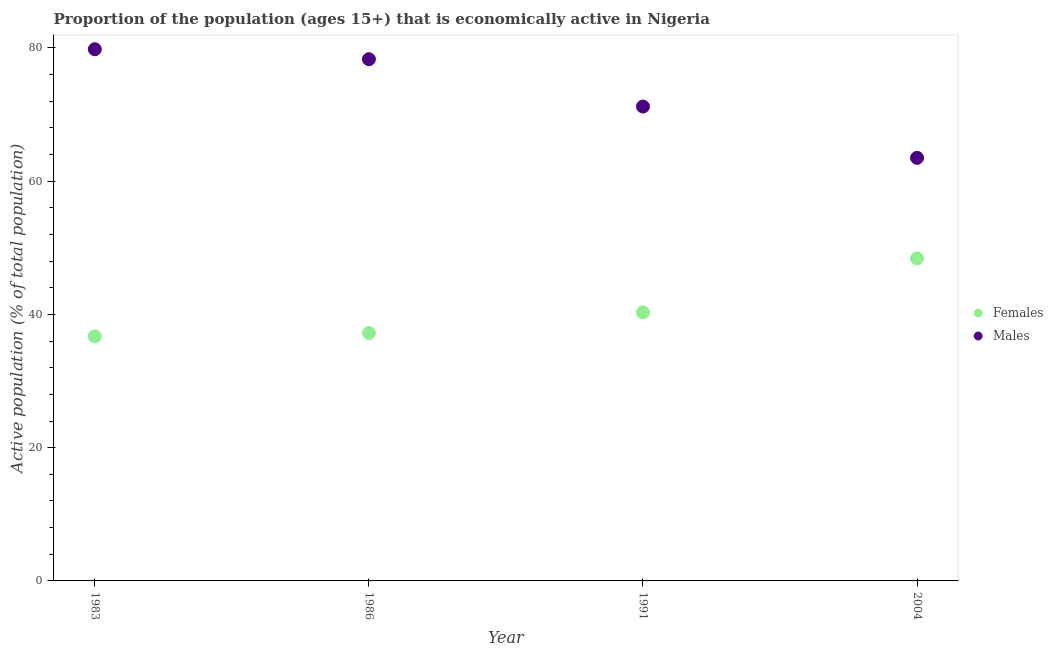How many different coloured dotlines are there?
Provide a succinct answer. 2. What is the percentage of economically active male population in 1991?
Offer a very short reply. 71.2. Across all years, what is the maximum percentage of economically active male population?
Your response must be concise. 79.8. Across all years, what is the minimum percentage of economically active male population?
Offer a terse response. 63.5. In which year was the percentage of economically active male population maximum?
Ensure brevity in your answer.  1983. In which year was the percentage of economically active male population minimum?
Make the answer very short. 2004. What is the total percentage of economically active female population in the graph?
Your response must be concise. 162.6. What is the difference between the percentage of economically active female population in 1986 and that in 2004?
Your answer should be very brief. -11.2. What is the difference between the percentage of economically active male population in 1983 and the percentage of economically active female population in 1991?
Provide a short and direct response. 39.5. What is the average percentage of economically active male population per year?
Your answer should be compact. 73.2. In the year 2004, what is the difference between the percentage of economically active female population and percentage of economically active male population?
Give a very brief answer. -15.1. What is the ratio of the percentage of economically active female population in 1991 to that in 2004?
Your response must be concise. 0.83. What is the difference between the highest and the second highest percentage of economically active female population?
Your response must be concise. 8.1. What is the difference between the highest and the lowest percentage of economically active female population?
Offer a terse response. 11.7. In how many years, is the percentage of economically active female population greater than the average percentage of economically active female population taken over all years?
Offer a terse response. 1. Is the sum of the percentage of economically active male population in 1986 and 1991 greater than the maximum percentage of economically active female population across all years?
Offer a terse response. Yes. Is the percentage of economically active female population strictly less than the percentage of economically active male population over the years?
Your answer should be compact. Yes. How many years are there in the graph?
Provide a short and direct response. 4. Does the graph contain any zero values?
Provide a short and direct response. No. Does the graph contain grids?
Your response must be concise. No. Where does the legend appear in the graph?
Offer a very short reply. Center right. How many legend labels are there?
Your answer should be compact. 2. How are the legend labels stacked?
Provide a succinct answer. Vertical. What is the title of the graph?
Your answer should be very brief. Proportion of the population (ages 15+) that is economically active in Nigeria. What is the label or title of the Y-axis?
Make the answer very short. Active population (% of total population). What is the Active population (% of total population) of Females in 1983?
Make the answer very short. 36.7. What is the Active population (% of total population) of Males in 1983?
Offer a terse response. 79.8. What is the Active population (% of total population) of Females in 1986?
Provide a short and direct response. 37.2. What is the Active population (% of total population) in Males in 1986?
Provide a short and direct response. 78.3. What is the Active population (% of total population) of Females in 1991?
Provide a short and direct response. 40.3. What is the Active population (% of total population) in Males in 1991?
Provide a succinct answer. 71.2. What is the Active population (% of total population) in Females in 2004?
Make the answer very short. 48.4. What is the Active population (% of total population) of Males in 2004?
Your answer should be compact. 63.5. Across all years, what is the maximum Active population (% of total population) of Females?
Your response must be concise. 48.4. Across all years, what is the maximum Active population (% of total population) in Males?
Ensure brevity in your answer.  79.8. Across all years, what is the minimum Active population (% of total population) in Females?
Provide a short and direct response. 36.7. Across all years, what is the minimum Active population (% of total population) of Males?
Provide a succinct answer. 63.5. What is the total Active population (% of total population) in Females in the graph?
Offer a terse response. 162.6. What is the total Active population (% of total population) of Males in the graph?
Offer a terse response. 292.8. What is the difference between the Active population (% of total population) in Males in 1983 and that in 1991?
Keep it short and to the point. 8.6. What is the difference between the Active population (% of total population) in Males in 1986 and that in 1991?
Offer a very short reply. 7.1. What is the difference between the Active population (% of total population) in Females in 1986 and that in 2004?
Provide a short and direct response. -11.2. What is the difference between the Active population (% of total population) in Males in 1991 and that in 2004?
Your answer should be compact. 7.7. What is the difference between the Active population (% of total population) in Females in 1983 and the Active population (% of total population) in Males in 1986?
Your response must be concise. -41.6. What is the difference between the Active population (% of total population) of Females in 1983 and the Active population (% of total population) of Males in 1991?
Provide a short and direct response. -34.5. What is the difference between the Active population (% of total population) in Females in 1983 and the Active population (% of total population) in Males in 2004?
Give a very brief answer. -26.8. What is the difference between the Active population (% of total population) in Females in 1986 and the Active population (% of total population) in Males in 1991?
Offer a terse response. -34. What is the difference between the Active population (% of total population) in Females in 1986 and the Active population (% of total population) in Males in 2004?
Provide a short and direct response. -26.3. What is the difference between the Active population (% of total population) of Females in 1991 and the Active population (% of total population) of Males in 2004?
Your answer should be compact. -23.2. What is the average Active population (% of total population) in Females per year?
Your answer should be compact. 40.65. What is the average Active population (% of total population) of Males per year?
Ensure brevity in your answer.  73.2. In the year 1983, what is the difference between the Active population (% of total population) in Females and Active population (% of total population) in Males?
Give a very brief answer. -43.1. In the year 1986, what is the difference between the Active population (% of total population) of Females and Active population (% of total population) of Males?
Your answer should be very brief. -41.1. In the year 1991, what is the difference between the Active population (% of total population) in Females and Active population (% of total population) in Males?
Provide a succinct answer. -30.9. In the year 2004, what is the difference between the Active population (% of total population) in Females and Active population (% of total population) in Males?
Provide a short and direct response. -15.1. What is the ratio of the Active population (% of total population) of Females in 1983 to that in 1986?
Keep it short and to the point. 0.99. What is the ratio of the Active population (% of total population) in Males in 1983 to that in 1986?
Keep it short and to the point. 1.02. What is the ratio of the Active population (% of total population) in Females in 1983 to that in 1991?
Your answer should be compact. 0.91. What is the ratio of the Active population (% of total population) of Males in 1983 to that in 1991?
Your answer should be very brief. 1.12. What is the ratio of the Active population (% of total population) in Females in 1983 to that in 2004?
Give a very brief answer. 0.76. What is the ratio of the Active population (% of total population) of Males in 1983 to that in 2004?
Offer a terse response. 1.26. What is the ratio of the Active population (% of total population) of Females in 1986 to that in 1991?
Make the answer very short. 0.92. What is the ratio of the Active population (% of total population) in Males in 1986 to that in 1991?
Your response must be concise. 1.1. What is the ratio of the Active population (% of total population) in Females in 1986 to that in 2004?
Make the answer very short. 0.77. What is the ratio of the Active population (% of total population) of Males in 1986 to that in 2004?
Ensure brevity in your answer.  1.23. What is the ratio of the Active population (% of total population) of Females in 1991 to that in 2004?
Your response must be concise. 0.83. What is the ratio of the Active population (% of total population) of Males in 1991 to that in 2004?
Provide a short and direct response. 1.12. What is the difference between the highest and the lowest Active population (% of total population) of Males?
Provide a short and direct response. 16.3. 